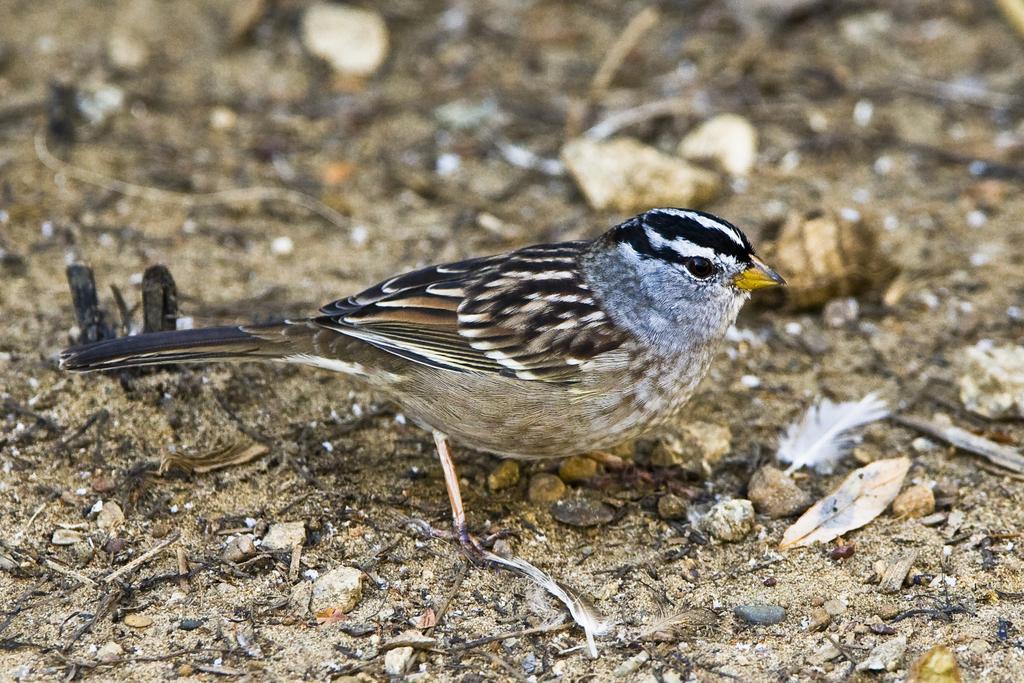How would you summarize this image in a sentence or two? In this image we can see a bird. The fur of the bird is in black,brown white color. The beak is in yellow color. 